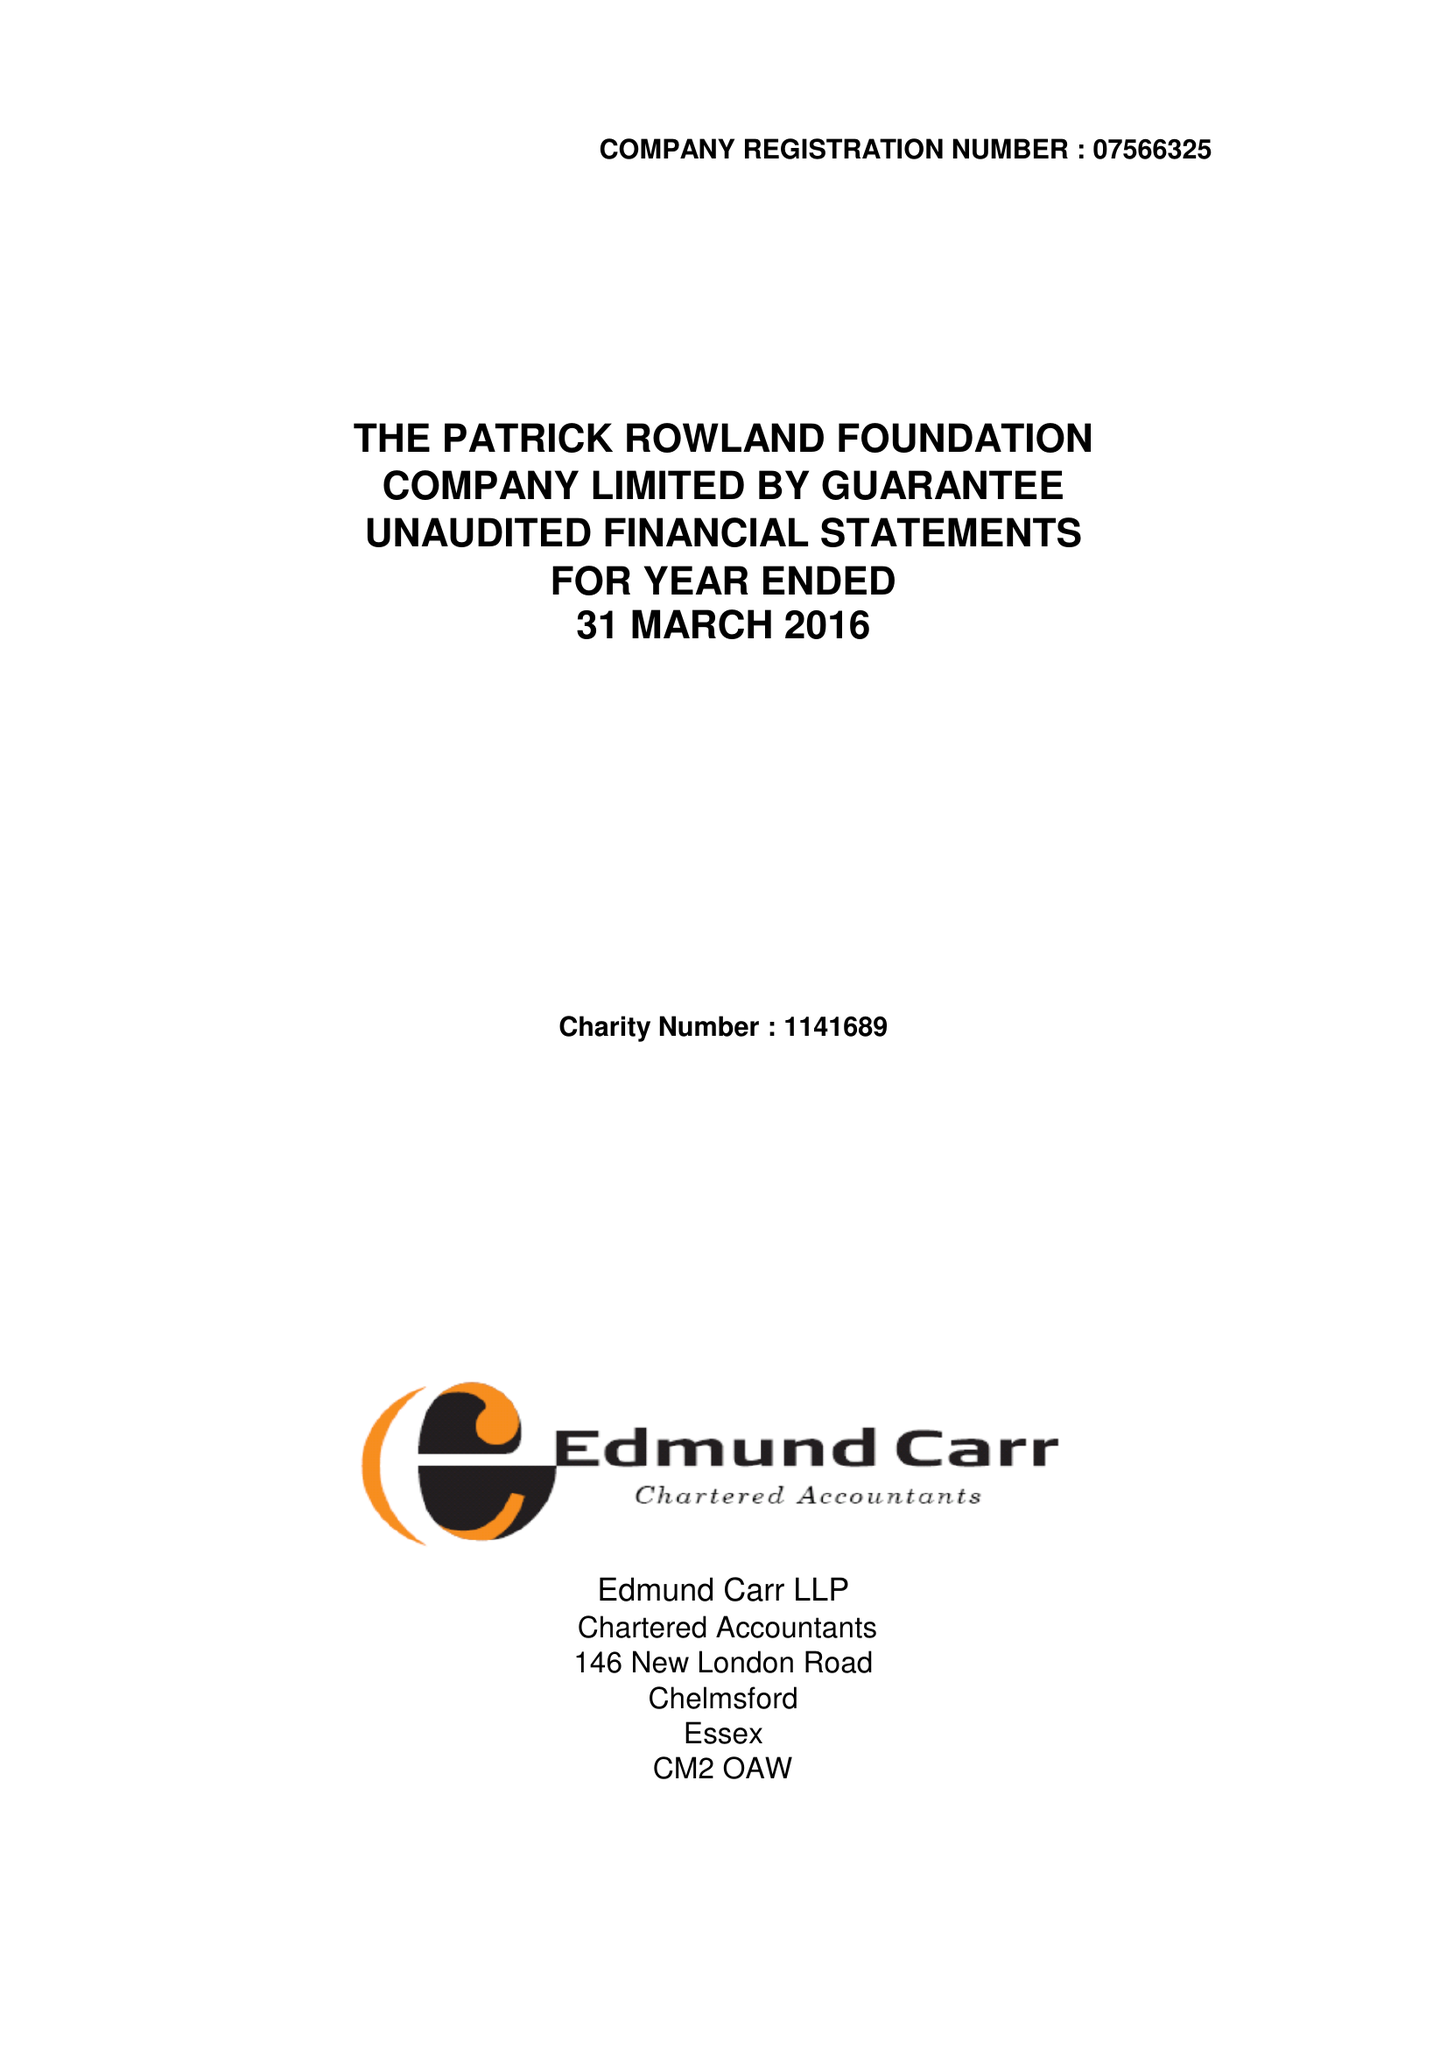What is the value for the address__street_line?
Answer the question using a single word or phrase. 146 NEW LONDON ROAD 